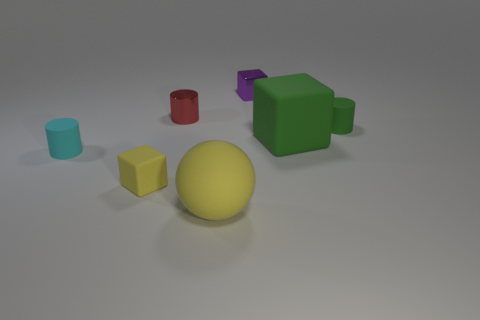Add 2 tiny purple blocks. How many objects exist? 9 Subtract all cylinders. How many objects are left? 4 Add 7 large green cubes. How many large green cubes exist? 8 Subtract 0 red spheres. How many objects are left? 7 Subtract all tiny rubber cylinders. Subtract all green matte things. How many objects are left? 3 Add 1 cyan matte cylinders. How many cyan matte cylinders are left? 2 